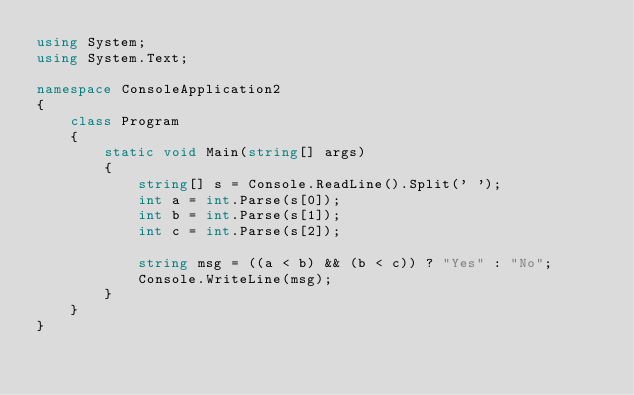<code> <loc_0><loc_0><loc_500><loc_500><_C#_>using System;
using System.Text;

namespace ConsoleApplication2
{
    class Program
    {
        static void Main(string[] args)
        {
            string[] s = Console.ReadLine().Split(' ');
            int a = int.Parse(s[0]);
            int b = int.Parse(s[1]);
            int c = int.Parse(s[2]);

            string msg = ((a < b) && (b < c)) ? "Yes" : "No";
            Console.WriteLine(msg);
        }
    }
}</code> 